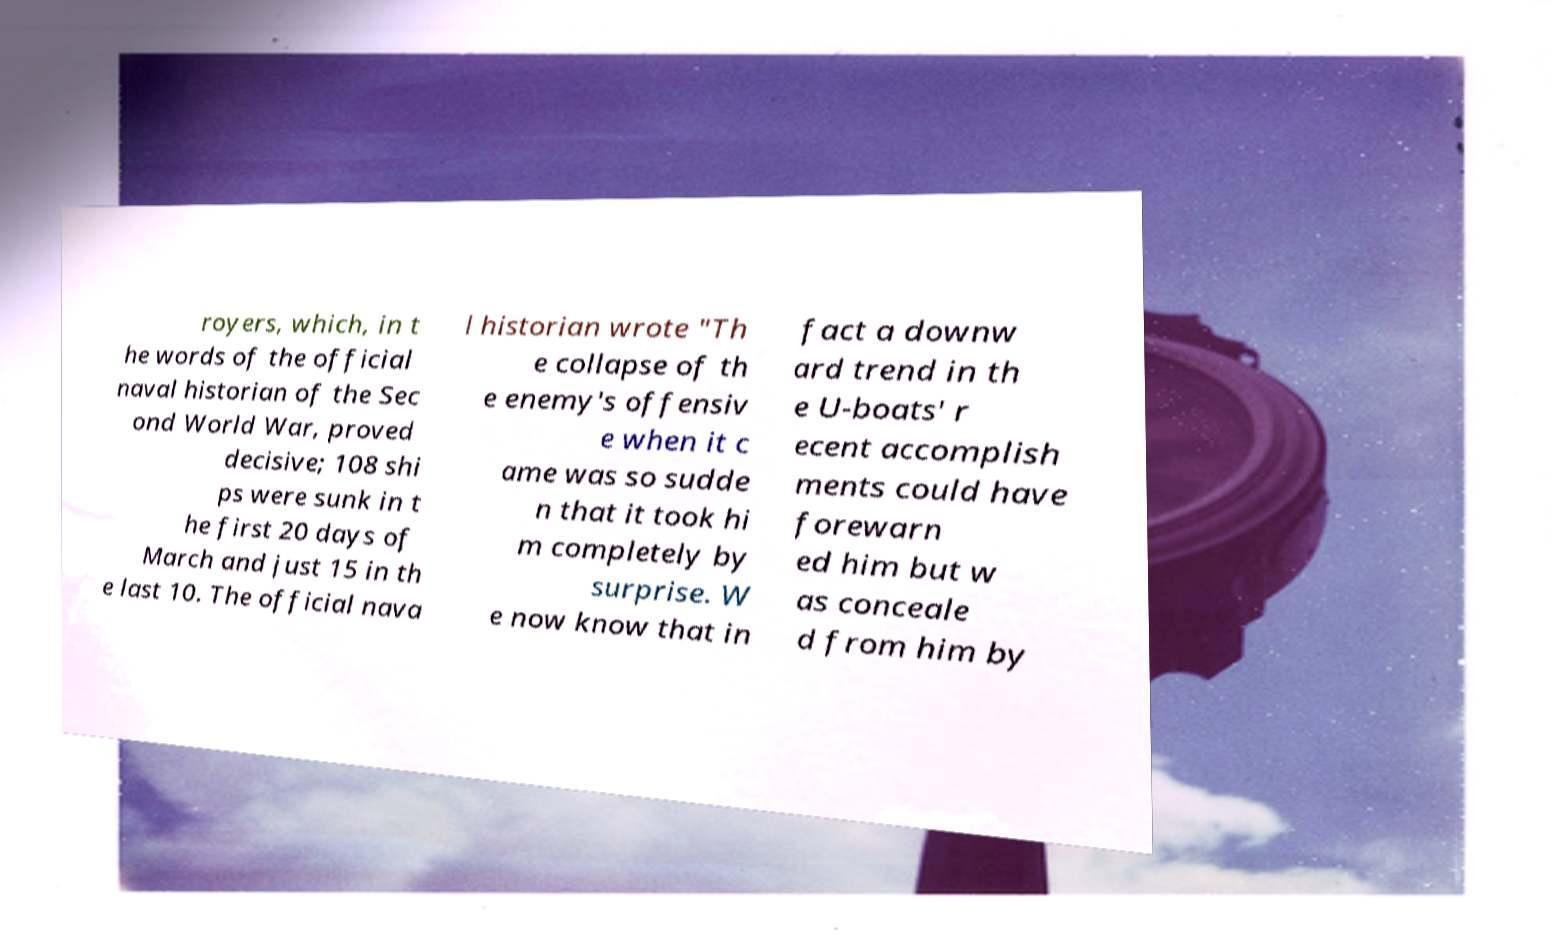There's text embedded in this image that I need extracted. Can you transcribe it verbatim? royers, which, in t he words of the official naval historian of the Sec ond World War, proved decisive; 108 shi ps were sunk in t he first 20 days of March and just 15 in th e last 10. The official nava l historian wrote "Th e collapse of th e enemy's offensiv e when it c ame was so sudde n that it took hi m completely by surprise. W e now know that in fact a downw ard trend in th e U-boats' r ecent accomplish ments could have forewarn ed him but w as conceale d from him by 